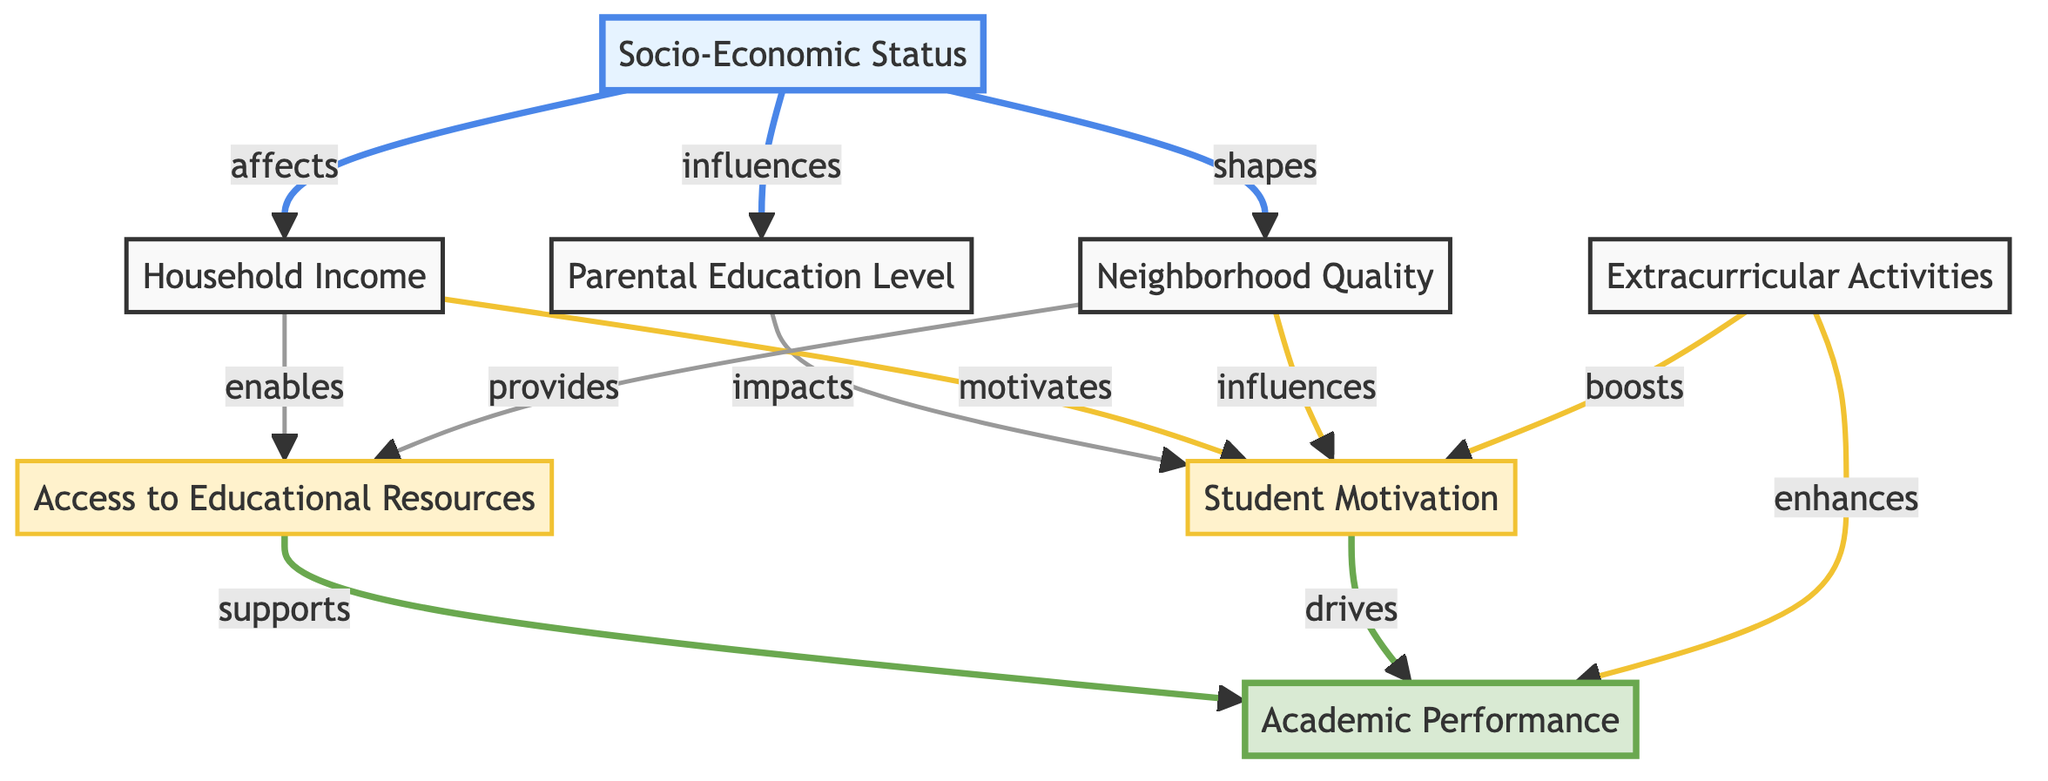What is the total number of nodes in the diagram? The diagram includes a list of nodes representing different factors influencing academic performance. By counting them, we find there are eight nodes in total.
Answer: 8 Which node directly influences Access to Educational Resources? From the diagram, Household Income and Neighborhood Quality are the only nodes that have direct edges to Access to Educational Resources, indicating they influence it.
Answer: Household Income, Neighborhood Quality What is the relationship between Student Motivation and Academic Performance? The diagram shows a direct edge between Student Motivation and Academic Performance labeled "drives," indicating a direct influence from Student Motivation to Academic Performance.
Answer: drives How many edges are directed towards Student Motivation? By examining the edges, it becomes clear that there are several nodes that have edges directed towards Student Motivation, specifically from Parental Education Level, Household Income, and Neighborhood Quality. In total, there are four edges directed towards it.
Answer: 4 Which socio-economic factor directly affects Academic Performance? Looking at the nodes in the diagram, both Access to Educational Resources and Student Motivation have direct edges leading to Academic Performance, making them socio-economic factors that directly affect it.
Answer: Access to Educational Resources, Student Motivation What is the unique characteristic of Extracurricular Activities in relation to other nodes? The diagram illustrates that Extracurricular Activities has a unique role, boosting both Student Motivation and Academic Performance without being influenced by any other node in this context.
Answer: Boosts Which node has the most direct influences on others? Upon inspecting the edges, Socio-Economic Status appears to have the widest reach as it influences three nodes directly (Parental Education Level, Household Income, Neighborhood Quality), making it the most influential.
Answer: Socio-Economic Status What is the effect of Household Income on Academic Performance? The diagram indicates a two-step pathway: Household Income influences both Student Motivation and Access to Educational Resources, which indirectly affects Academic Performance, demonstrating a cascaded influence.
Answer: Indirect effect through two nodes How many nodes are classified as intermediate in the diagram? Reviewing the node classifications, we see that Student Motivation and Access to Educational Resources are the only two nodes classified as intermediate. This can be counted directly from the visual distinctions made in the diagram.
Answer: 2 